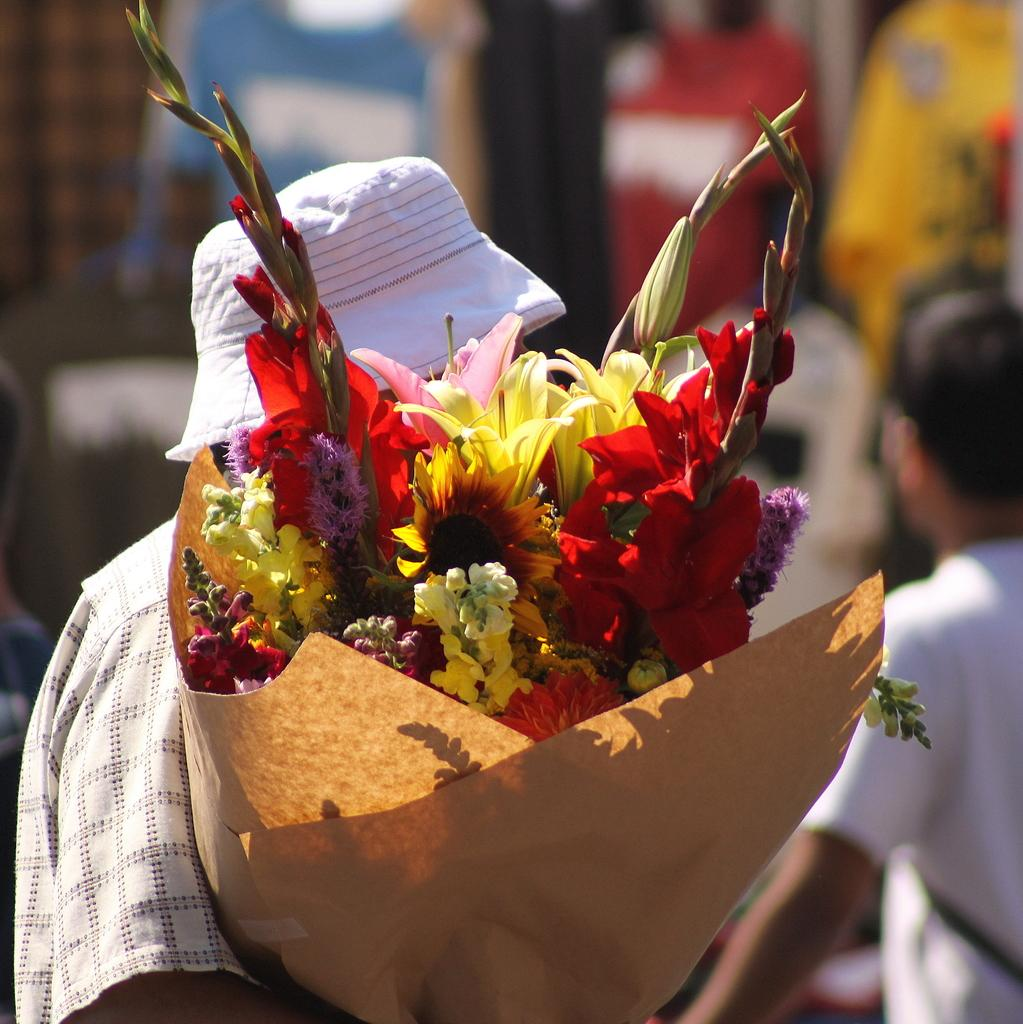What is the person in the image holding? The person is holding different types of flowers in the image. Can you describe the background of the image? There is a group of people at the back of the image. How would you describe the quality of the image? The image is blurry. What type of bread is being offered to the person holding flowers in the image? There is no bread present in the image; the person is holding different types of flowers. 